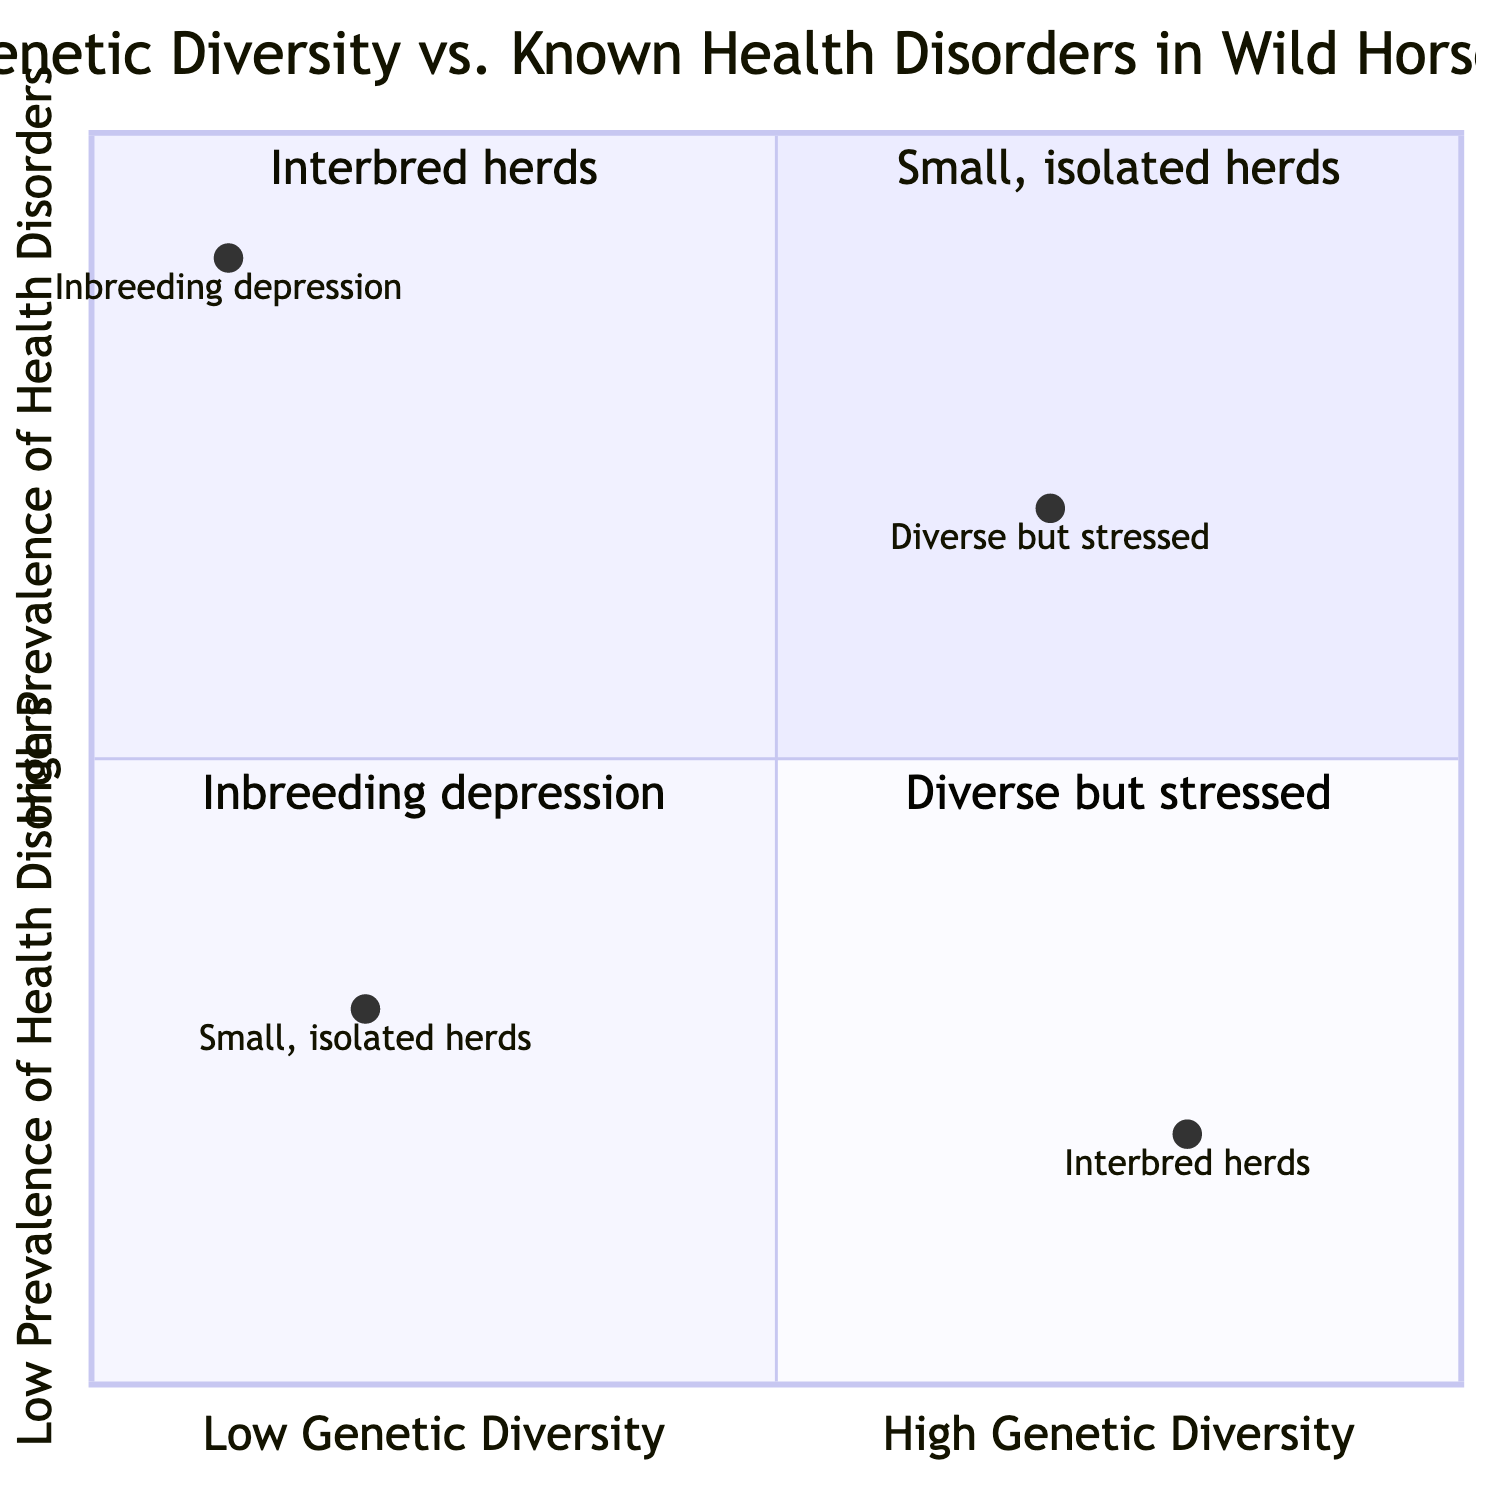What are the characteristics of Quadrant I? Quadrant I is defined as having low genetic diversity and low health disorders. The examples show small, isolated herds with minimal human intervention and limited inbreeding, which contribute to fewer health issues.
Answer: Low Genetic Diversity, Low Health Disorders How many quadrants are represented in the diagram? The diagram consists of four distinct quadrants, each representing different combinations of genetic diversity and health disorder prevalence.
Answer: Four What health disorders are associated with low genetic diversity in Quadrant III? Quadrant III indicates high health disorders in populations with low genetic diversity, specifically highlighting inbreeding depression and increased susceptibility to diseases such as Equine Degenerative Myeloencephalopathy.
Answer: Equine Degenerative Myeloencephalopathy Which quadrant represents interbred herds? The quadrant representing interbred herds is Quadrant II, which exhibits high genetic diversity and low health disorder prevalence. The examples include herds among neighboring regions with a diverse gene pool.
Answer: Quadrant II What is the relationship between genetic diversity and health disorders in Quadrant IV? In Quadrant IV, there is high genetic diversity coupled with high health disorders. This suggests that even with genetic diversity from diverse breeds, environmental stressors and exposure to infectious diseases like Equine Infectious Anemia affect health.
Answer: High Genetic Diversity, High Health Disorders Which quadrant contains the example of “small, isolated herds”? The example of “small, isolated herds” is found in Quadrant I, which denotes a scenario of low genetic diversity and low health disorders, suggesting minimal external influences.
Answer: Quadrant I Which quadrant is associated with increased susceptibility to diseases? Quadrant III is associated with increased susceptibility to diseases due to low genetic diversity, leading to issues like inbreeding depression and higher chances of health disorders.
Answer: Quadrant III What is the significance of diverse gene pools as indicated in the quadrants? Diverse gene pools, as indicated in Quadrant II, contribute to lower susceptibility to genetic diseases, enhancing the overall health of wild horse populations by reducing the prevalence of health disorders.
Answer: Lower Susceptibility What type of herds are featured in Quadrant I? Quadrant I features small, isolated herds, highlighting a situation where there is minimal human intervention and low health disorder prevalence due to low genetic diversity.
Answer: Small, isolated herds 